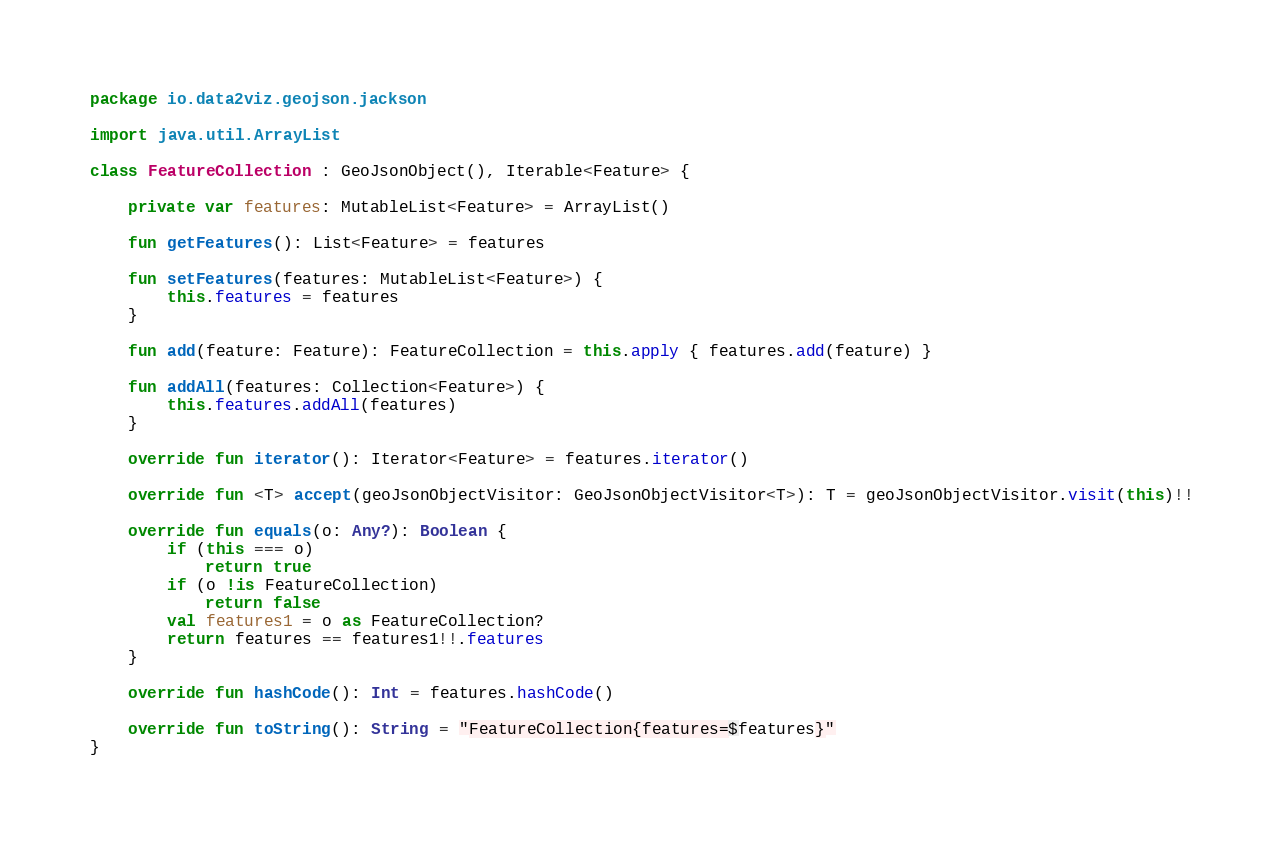<code> <loc_0><loc_0><loc_500><loc_500><_Kotlin_>package io.data2viz.geojson.jackson

import java.util.ArrayList

class FeatureCollection : GeoJsonObject(), Iterable<Feature> {

    private var features: MutableList<Feature> = ArrayList()

    fun getFeatures(): List<Feature> = features

    fun setFeatures(features: MutableList<Feature>) {
        this.features = features
    }

    fun add(feature: Feature): FeatureCollection = this.apply { features.add(feature) }

    fun addAll(features: Collection<Feature>) {
        this.features.addAll(features)
    }

    override fun iterator(): Iterator<Feature> = features.iterator()

    override fun <T> accept(geoJsonObjectVisitor: GeoJsonObjectVisitor<T>): T = geoJsonObjectVisitor.visit(this)!!

    override fun equals(o: Any?): Boolean {
        if (this === o)
            return true
        if (o !is FeatureCollection)
            return false
        val features1 = o as FeatureCollection?
        return features == features1!!.features
    }

    override fun hashCode(): Int = features.hashCode()

    override fun toString(): String = "FeatureCollection{features=$features}"
}
</code> 